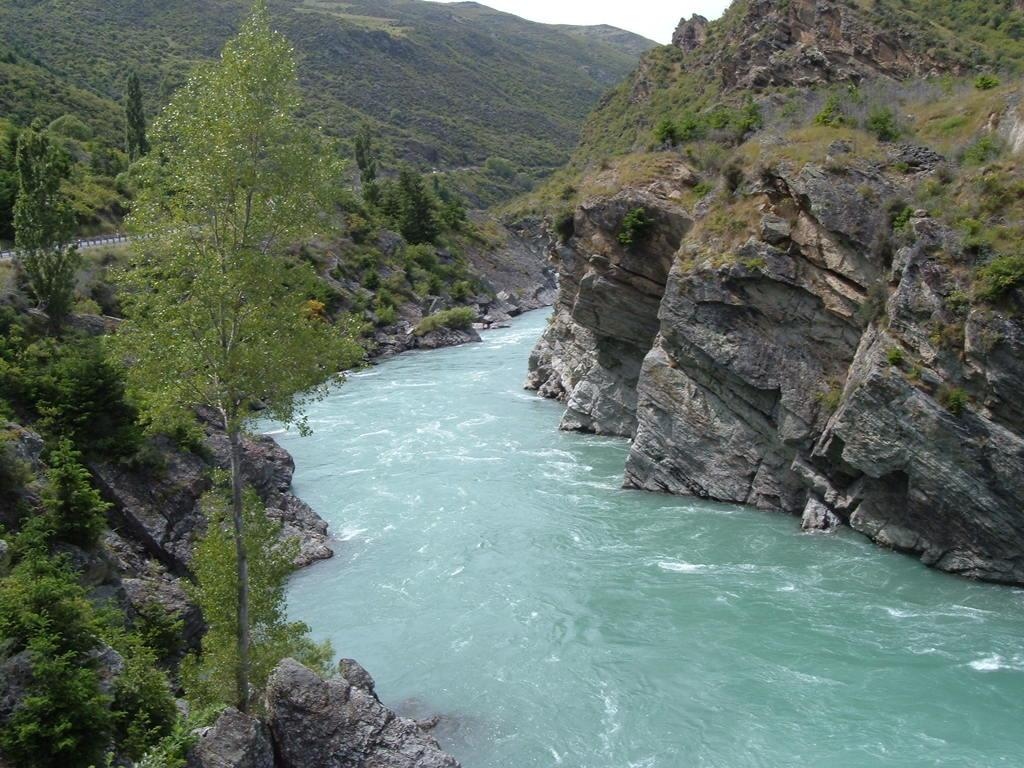What type of vegetation can be seen in the image? There are trees in the image. What type of natural landform is visible in the image? There are mountains in the image. What type of geological feature can be seen in the image? There are rocks in the image. What body of water can be seen in the image? There is water visible in the image. Can you tell me how many rats are sitting on the rocks in the image? There are no rats present in the image; it features trees, mountains, rocks, and water. What type of view is depicted in the image? The image does not depict a specific view; it simply shows trees, mountains, rocks, and water. 